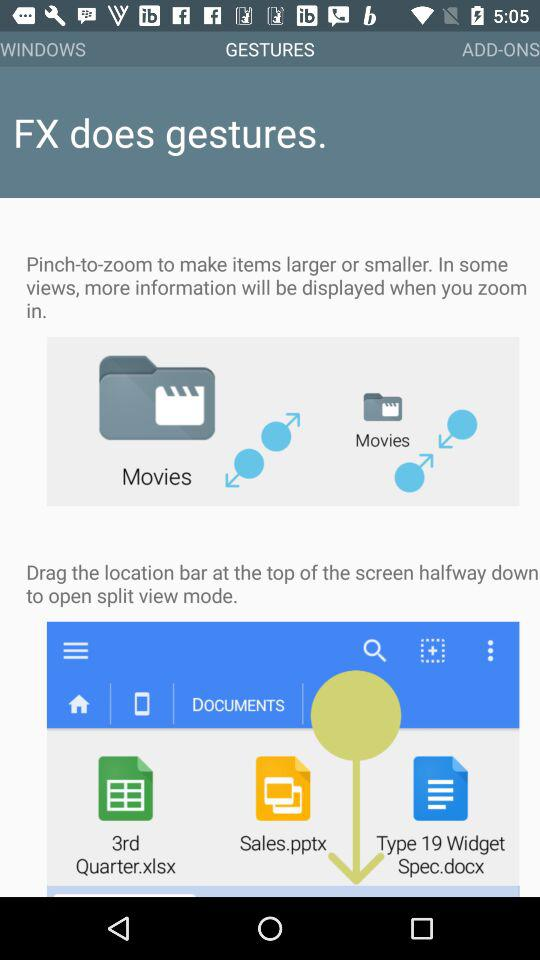How many steps are there in "ADD-ONS"?
When the provided information is insufficient, respond with <no answer>. <no answer> 